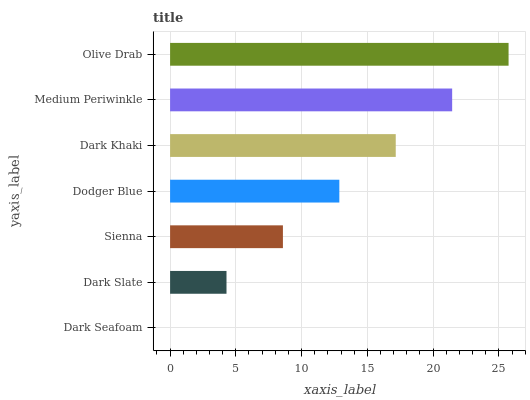Is Dark Seafoam the minimum?
Answer yes or no. Yes. Is Olive Drab the maximum?
Answer yes or no. Yes. Is Dark Slate the minimum?
Answer yes or no. No. Is Dark Slate the maximum?
Answer yes or no. No. Is Dark Slate greater than Dark Seafoam?
Answer yes or no. Yes. Is Dark Seafoam less than Dark Slate?
Answer yes or no. Yes. Is Dark Seafoam greater than Dark Slate?
Answer yes or no. No. Is Dark Slate less than Dark Seafoam?
Answer yes or no. No. Is Dodger Blue the high median?
Answer yes or no. Yes. Is Dodger Blue the low median?
Answer yes or no. Yes. Is Dark Khaki the high median?
Answer yes or no. No. Is Dark Seafoam the low median?
Answer yes or no. No. 